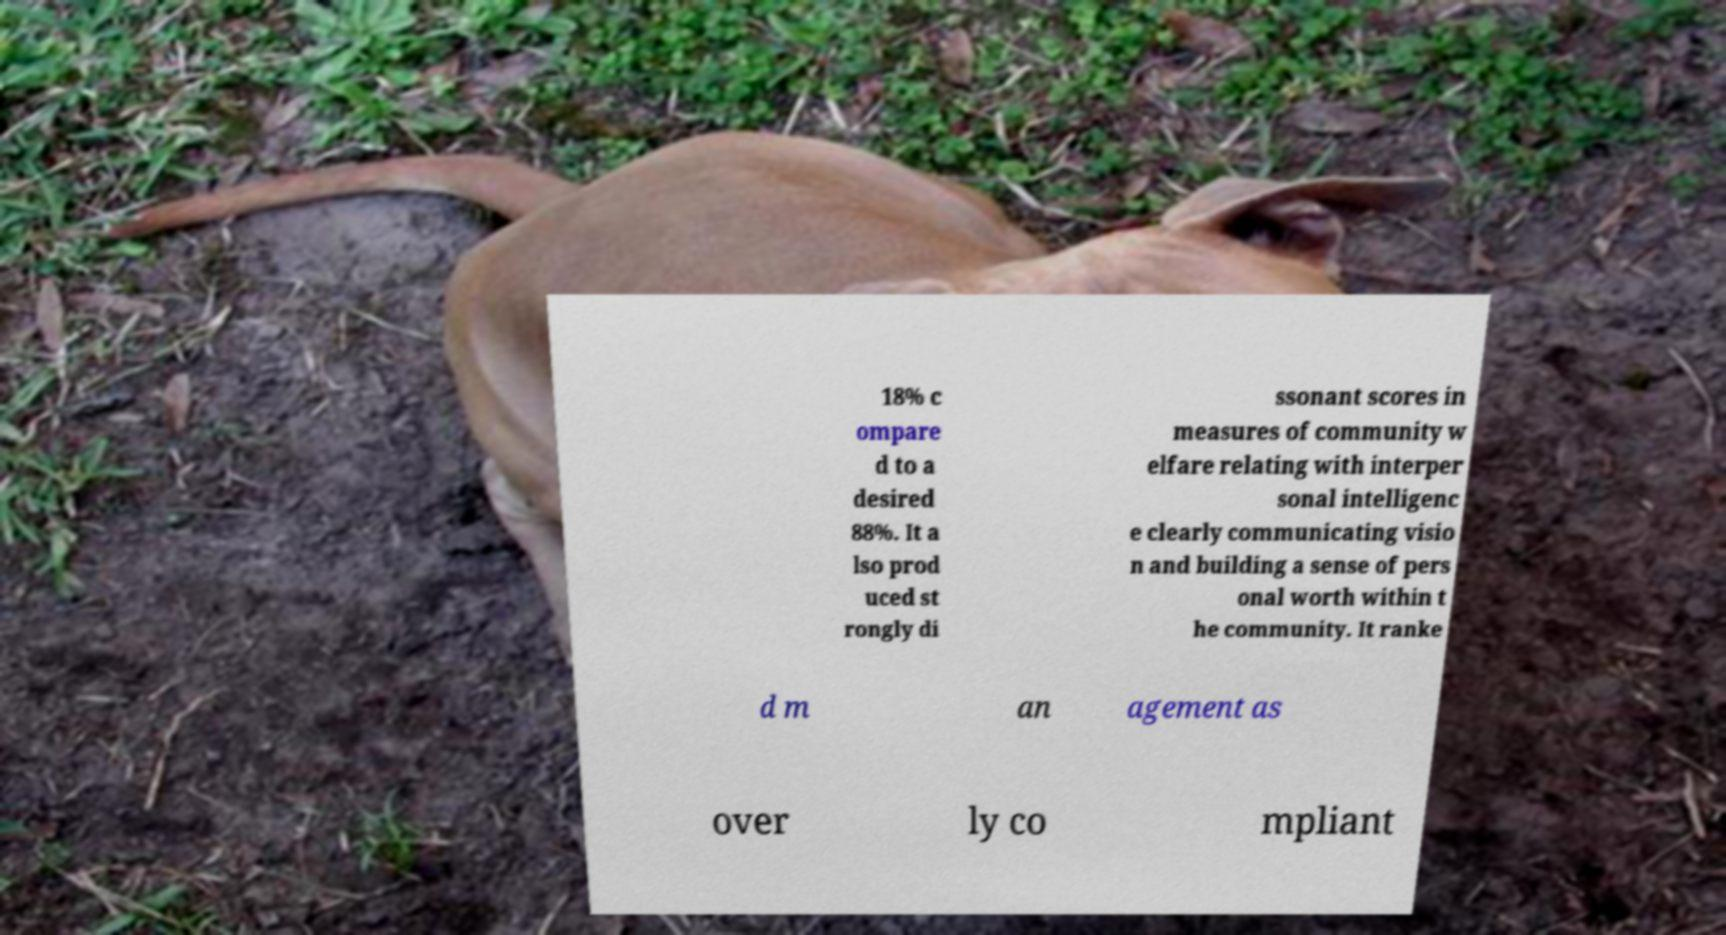Can you read and provide the text displayed in the image?This photo seems to have some interesting text. Can you extract and type it out for me? 18% c ompare d to a desired 88%. It a lso prod uced st rongly di ssonant scores in measures of community w elfare relating with interper sonal intelligenc e clearly communicating visio n and building a sense of pers onal worth within t he community. It ranke d m an agement as over ly co mpliant 